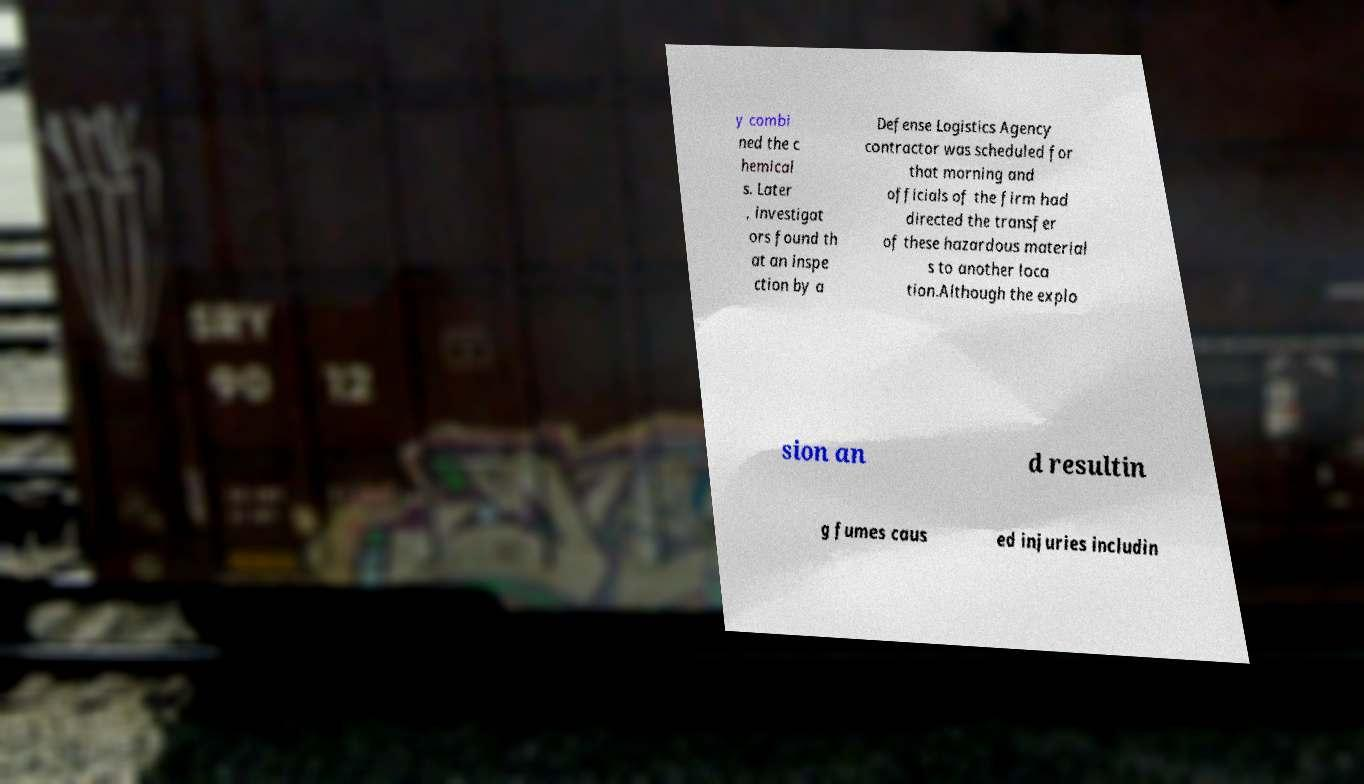Please read and relay the text visible in this image. What does it say? y combi ned the c hemical s. Later , investigat ors found th at an inspe ction by a Defense Logistics Agency contractor was scheduled for that morning and officials of the firm had directed the transfer of these hazardous material s to another loca tion.Although the explo sion an d resultin g fumes caus ed injuries includin 